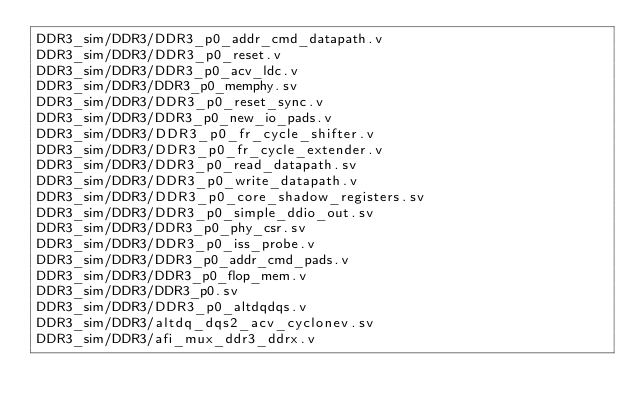Convert code to text. <code><loc_0><loc_0><loc_500><loc_500><_FORTRAN_>DDR3_sim/DDR3/DDR3_p0_addr_cmd_datapath.v
DDR3_sim/DDR3/DDR3_p0_reset.v
DDR3_sim/DDR3/DDR3_p0_acv_ldc.v
DDR3_sim/DDR3/DDR3_p0_memphy.sv
DDR3_sim/DDR3/DDR3_p0_reset_sync.v
DDR3_sim/DDR3/DDR3_p0_new_io_pads.v
DDR3_sim/DDR3/DDR3_p0_fr_cycle_shifter.v
DDR3_sim/DDR3/DDR3_p0_fr_cycle_extender.v
DDR3_sim/DDR3/DDR3_p0_read_datapath.sv
DDR3_sim/DDR3/DDR3_p0_write_datapath.v
DDR3_sim/DDR3/DDR3_p0_core_shadow_registers.sv
DDR3_sim/DDR3/DDR3_p0_simple_ddio_out.sv
DDR3_sim/DDR3/DDR3_p0_phy_csr.sv
DDR3_sim/DDR3/DDR3_p0_iss_probe.v
DDR3_sim/DDR3/DDR3_p0_addr_cmd_pads.v
DDR3_sim/DDR3/DDR3_p0_flop_mem.v
DDR3_sim/DDR3/DDR3_p0.sv
DDR3_sim/DDR3/DDR3_p0_altdqdqs.v
DDR3_sim/DDR3/altdq_dqs2_acv_cyclonev.sv
DDR3_sim/DDR3/afi_mux_ddr3_ddrx.v
</code> 